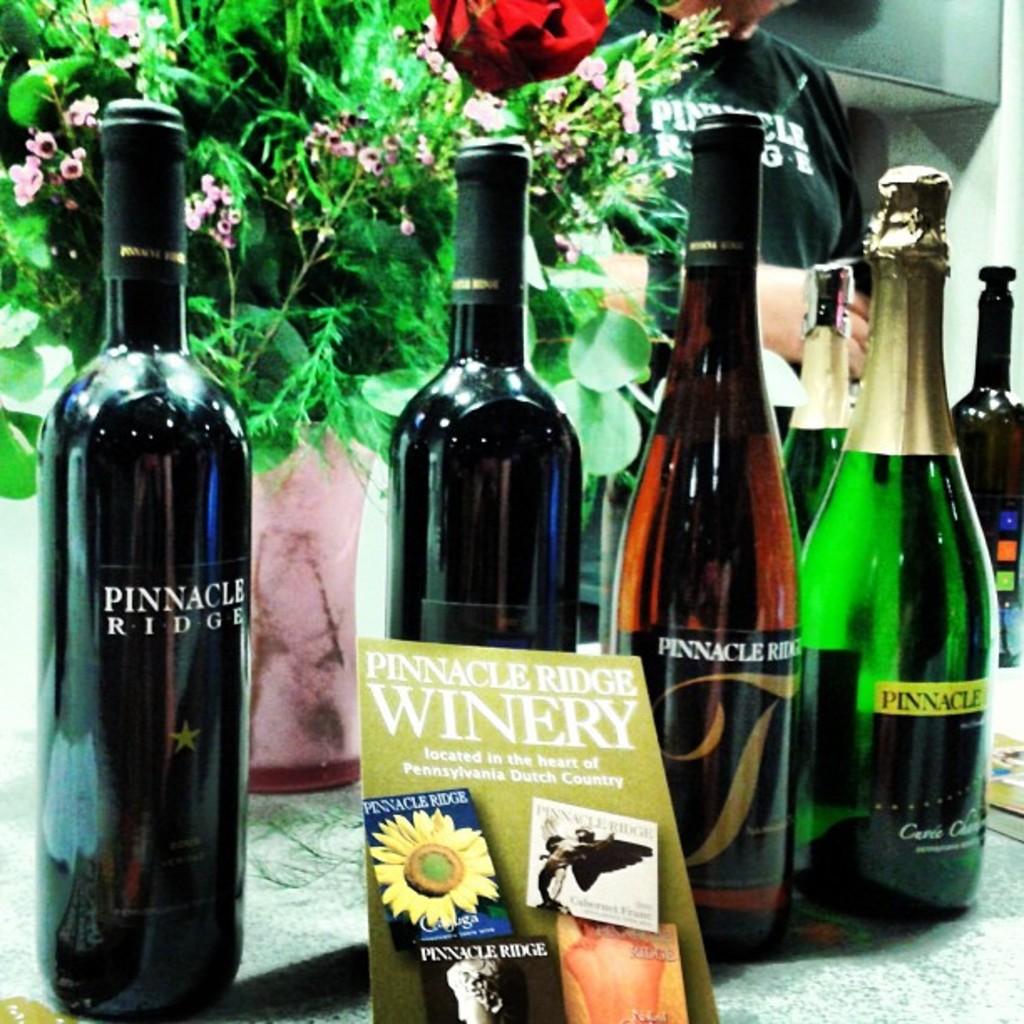What is the name of this winery?
Ensure brevity in your answer.  Pinnacle ridge. What kind of wine is shown?
Your answer should be very brief. Pinnacle ridge. 